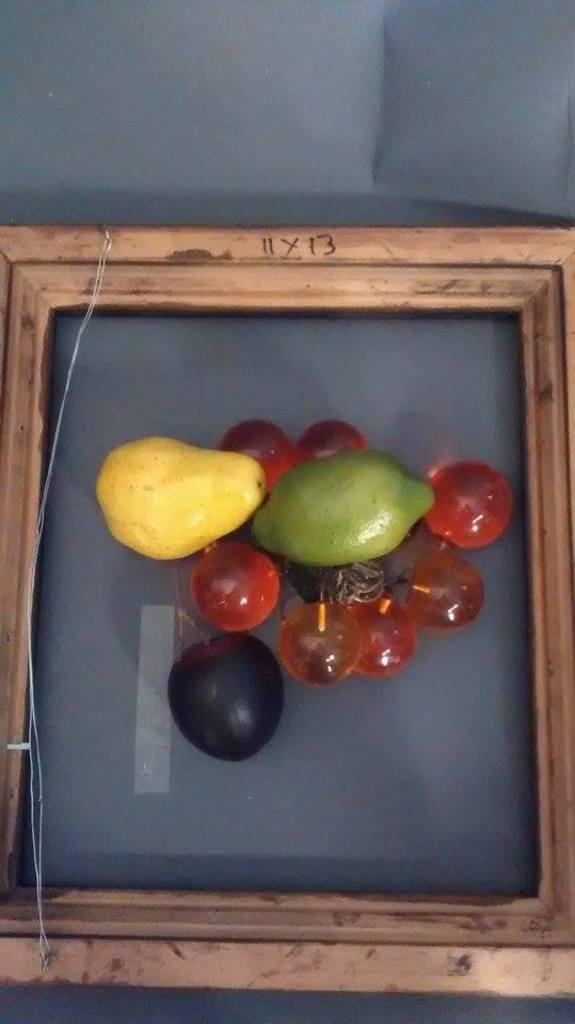What type of frame is visible in the image? There is a wooden frame in the image. What is contained within the wooden frame? The wooden frame contains fruits. Can you name some specific fruits that are included in the frame? The fruits include pears, Jamun, and some berries. What type of glass is used to make the argument in the image? There is no glass or argument present in the image; it features a wooden frame containing fruits. 